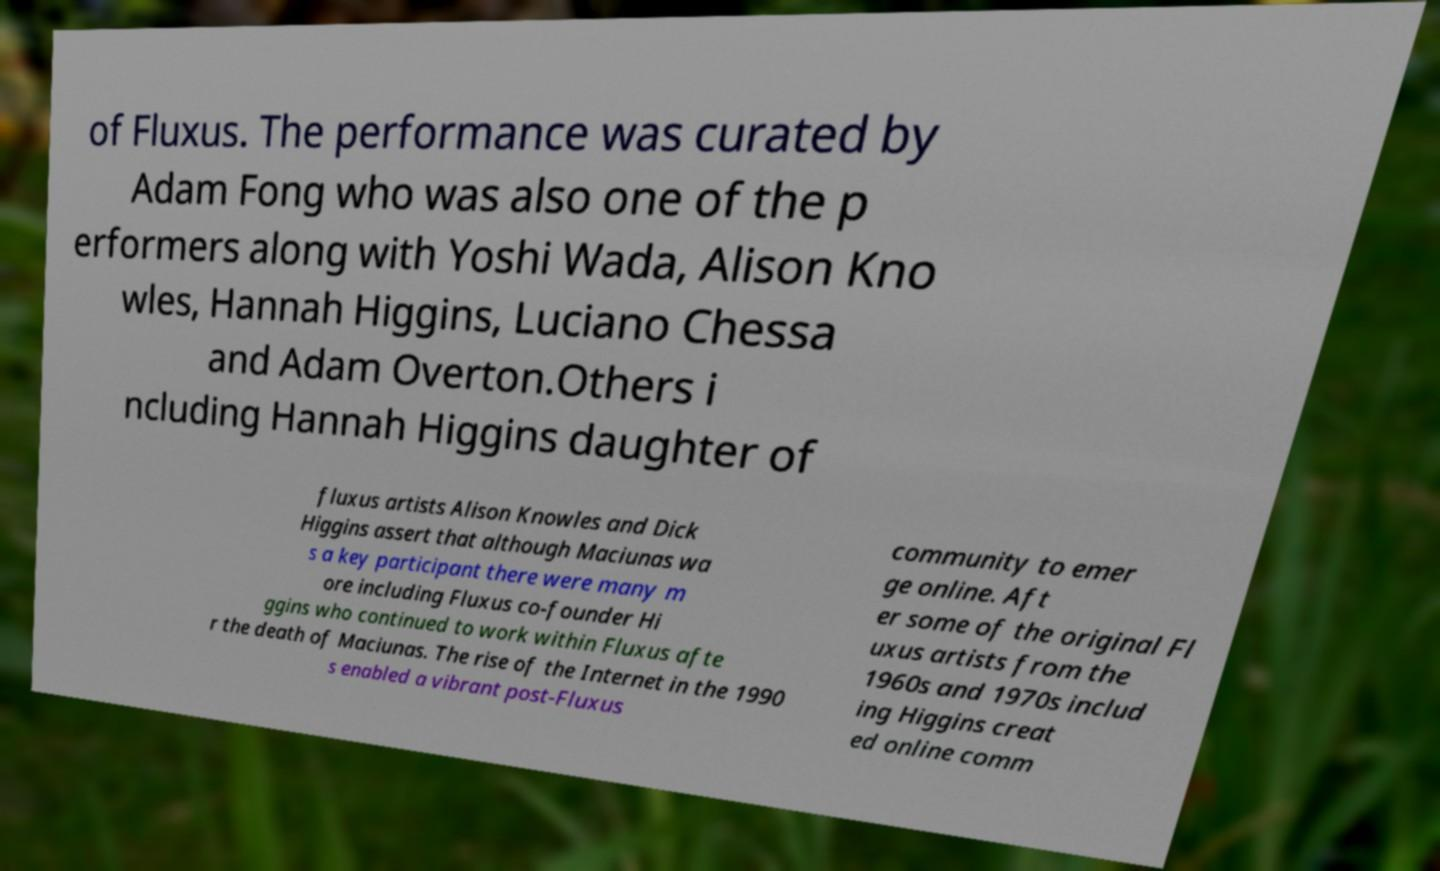Please identify and transcribe the text found in this image. of Fluxus. The performance was curated by Adam Fong who was also one of the p erformers along with Yoshi Wada, Alison Kno wles, Hannah Higgins, Luciano Chessa and Adam Overton.Others i ncluding Hannah Higgins daughter of fluxus artists Alison Knowles and Dick Higgins assert that although Maciunas wa s a key participant there were many m ore including Fluxus co-founder Hi ggins who continued to work within Fluxus afte r the death of Maciunas. The rise of the Internet in the 1990 s enabled a vibrant post-Fluxus community to emer ge online. Aft er some of the original Fl uxus artists from the 1960s and 1970s includ ing Higgins creat ed online comm 